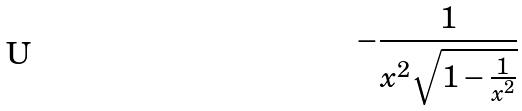Convert formula to latex. <formula><loc_0><loc_0><loc_500><loc_500>- \frac { 1 } { x ^ { 2 } \sqrt { 1 - \frac { 1 } { x ^ { 2 } } } }</formula> 